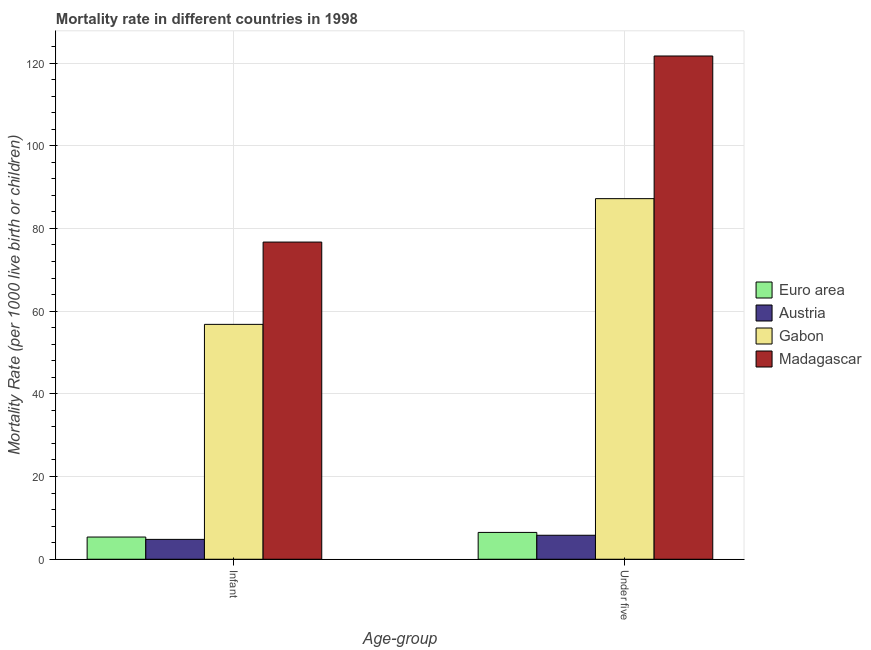What is the label of the 2nd group of bars from the left?
Ensure brevity in your answer.  Under five. Across all countries, what is the maximum under-5 mortality rate?
Offer a terse response. 121.7. In which country was the infant mortality rate maximum?
Provide a short and direct response. Madagascar. In which country was the infant mortality rate minimum?
Give a very brief answer. Austria. What is the total under-5 mortality rate in the graph?
Your answer should be compact. 221.19. What is the difference between the infant mortality rate in Austria and that in Gabon?
Provide a succinct answer. -52. What is the difference between the infant mortality rate in Austria and the under-5 mortality rate in Madagascar?
Your answer should be very brief. -116.9. What is the average infant mortality rate per country?
Provide a short and direct response. 35.92. What is the difference between the infant mortality rate and under-5 mortality rate in Gabon?
Offer a very short reply. -30.4. In how many countries, is the under-5 mortality rate greater than 60 ?
Your answer should be very brief. 2. What is the ratio of the infant mortality rate in Madagascar to that in Euro area?
Provide a short and direct response. 14.29. Is the under-5 mortality rate in Euro area less than that in Madagascar?
Your response must be concise. Yes. What does the 1st bar from the left in Under five represents?
Make the answer very short. Euro area. What is the difference between two consecutive major ticks on the Y-axis?
Offer a terse response. 20. Are the values on the major ticks of Y-axis written in scientific E-notation?
Your response must be concise. No. Does the graph contain any zero values?
Provide a succinct answer. No. Where does the legend appear in the graph?
Your answer should be compact. Center right. How many legend labels are there?
Offer a very short reply. 4. How are the legend labels stacked?
Keep it short and to the point. Vertical. What is the title of the graph?
Give a very brief answer. Mortality rate in different countries in 1998. Does "Kenya" appear as one of the legend labels in the graph?
Give a very brief answer. No. What is the label or title of the X-axis?
Keep it short and to the point. Age-group. What is the label or title of the Y-axis?
Your answer should be compact. Mortality Rate (per 1000 live birth or children). What is the Mortality Rate (per 1000 live birth or children) of Euro area in Infant?
Offer a terse response. 5.37. What is the Mortality Rate (per 1000 live birth or children) of Gabon in Infant?
Your answer should be very brief. 56.8. What is the Mortality Rate (per 1000 live birth or children) of Madagascar in Infant?
Provide a succinct answer. 76.7. What is the Mortality Rate (per 1000 live birth or children) of Euro area in Under five?
Give a very brief answer. 6.49. What is the Mortality Rate (per 1000 live birth or children) in Austria in Under five?
Provide a succinct answer. 5.8. What is the Mortality Rate (per 1000 live birth or children) in Gabon in Under five?
Ensure brevity in your answer.  87.2. What is the Mortality Rate (per 1000 live birth or children) of Madagascar in Under five?
Keep it short and to the point. 121.7. Across all Age-group, what is the maximum Mortality Rate (per 1000 live birth or children) in Euro area?
Make the answer very short. 6.49. Across all Age-group, what is the maximum Mortality Rate (per 1000 live birth or children) in Austria?
Your answer should be compact. 5.8. Across all Age-group, what is the maximum Mortality Rate (per 1000 live birth or children) in Gabon?
Provide a short and direct response. 87.2. Across all Age-group, what is the maximum Mortality Rate (per 1000 live birth or children) in Madagascar?
Offer a very short reply. 121.7. Across all Age-group, what is the minimum Mortality Rate (per 1000 live birth or children) of Euro area?
Offer a very short reply. 5.37. Across all Age-group, what is the minimum Mortality Rate (per 1000 live birth or children) in Gabon?
Provide a short and direct response. 56.8. Across all Age-group, what is the minimum Mortality Rate (per 1000 live birth or children) in Madagascar?
Offer a terse response. 76.7. What is the total Mortality Rate (per 1000 live birth or children) in Euro area in the graph?
Your response must be concise. 11.85. What is the total Mortality Rate (per 1000 live birth or children) in Gabon in the graph?
Ensure brevity in your answer.  144. What is the total Mortality Rate (per 1000 live birth or children) in Madagascar in the graph?
Provide a short and direct response. 198.4. What is the difference between the Mortality Rate (per 1000 live birth or children) in Euro area in Infant and that in Under five?
Provide a succinct answer. -1.12. What is the difference between the Mortality Rate (per 1000 live birth or children) in Gabon in Infant and that in Under five?
Keep it short and to the point. -30.4. What is the difference between the Mortality Rate (per 1000 live birth or children) in Madagascar in Infant and that in Under five?
Your answer should be compact. -45. What is the difference between the Mortality Rate (per 1000 live birth or children) in Euro area in Infant and the Mortality Rate (per 1000 live birth or children) in Austria in Under five?
Your answer should be very brief. -0.43. What is the difference between the Mortality Rate (per 1000 live birth or children) in Euro area in Infant and the Mortality Rate (per 1000 live birth or children) in Gabon in Under five?
Keep it short and to the point. -81.83. What is the difference between the Mortality Rate (per 1000 live birth or children) in Euro area in Infant and the Mortality Rate (per 1000 live birth or children) in Madagascar in Under five?
Your response must be concise. -116.33. What is the difference between the Mortality Rate (per 1000 live birth or children) of Austria in Infant and the Mortality Rate (per 1000 live birth or children) of Gabon in Under five?
Your answer should be very brief. -82.4. What is the difference between the Mortality Rate (per 1000 live birth or children) in Austria in Infant and the Mortality Rate (per 1000 live birth or children) in Madagascar in Under five?
Your answer should be compact. -116.9. What is the difference between the Mortality Rate (per 1000 live birth or children) in Gabon in Infant and the Mortality Rate (per 1000 live birth or children) in Madagascar in Under five?
Offer a very short reply. -64.9. What is the average Mortality Rate (per 1000 live birth or children) in Euro area per Age-group?
Provide a succinct answer. 5.93. What is the average Mortality Rate (per 1000 live birth or children) in Austria per Age-group?
Make the answer very short. 5.3. What is the average Mortality Rate (per 1000 live birth or children) in Madagascar per Age-group?
Provide a short and direct response. 99.2. What is the difference between the Mortality Rate (per 1000 live birth or children) of Euro area and Mortality Rate (per 1000 live birth or children) of Austria in Infant?
Keep it short and to the point. 0.57. What is the difference between the Mortality Rate (per 1000 live birth or children) in Euro area and Mortality Rate (per 1000 live birth or children) in Gabon in Infant?
Offer a terse response. -51.43. What is the difference between the Mortality Rate (per 1000 live birth or children) in Euro area and Mortality Rate (per 1000 live birth or children) in Madagascar in Infant?
Ensure brevity in your answer.  -71.33. What is the difference between the Mortality Rate (per 1000 live birth or children) of Austria and Mortality Rate (per 1000 live birth or children) of Gabon in Infant?
Make the answer very short. -52. What is the difference between the Mortality Rate (per 1000 live birth or children) in Austria and Mortality Rate (per 1000 live birth or children) in Madagascar in Infant?
Offer a very short reply. -71.9. What is the difference between the Mortality Rate (per 1000 live birth or children) in Gabon and Mortality Rate (per 1000 live birth or children) in Madagascar in Infant?
Keep it short and to the point. -19.9. What is the difference between the Mortality Rate (per 1000 live birth or children) of Euro area and Mortality Rate (per 1000 live birth or children) of Austria in Under five?
Provide a short and direct response. 0.69. What is the difference between the Mortality Rate (per 1000 live birth or children) in Euro area and Mortality Rate (per 1000 live birth or children) in Gabon in Under five?
Provide a short and direct response. -80.71. What is the difference between the Mortality Rate (per 1000 live birth or children) in Euro area and Mortality Rate (per 1000 live birth or children) in Madagascar in Under five?
Your answer should be very brief. -115.21. What is the difference between the Mortality Rate (per 1000 live birth or children) in Austria and Mortality Rate (per 1000 live birth or children) in Gabon in Under five?
Make the answer very short. -81.4. What is the difference between the Mortality Rate (per 1000 live birth or children) of Austria and Mortality Rate (per 1000 live birth or children) of Madagascar in Under five?
Make the answer very short. -115.9. What is the difference between the Mortality Rate (per 1000 live birth or children) of Gabon and Mortality Rate (per 1000 live birth or children) of Madagascar in Under five?
Offer a very short reply. -34.5. What is the ratio of the Mortality Rate (per 1000 live birth or children) in Euro area in Infant to that in Under five?
Offer a very short reply. 0.83. What is the ratio of the Mortality Rate (per 1000 live birth or children) of Austria in Infant to that in Under five?
Ensure brevity in your answer.  0.83. What is the ratio of the Mortality Rate (per 1000 live birth or children) of Gabon in Infant to that in Under five?
Keep it short and to the point. 0.65. What is the ratio of the Mortality Rate (per 1000 live birth or children) in Madagascar in Infant to that in Under five?
Provide a succinct answer. 0.63. What is the difference between the highest and the second highest Mortality Rate (per 1000 live birth or children) of Euro area?
Provide a short and direct response. 1.12. What is the difference between the highest and the second highest Mortality Rate (per 1000 live birth or children) in Gabon?
Offer a very short reply. 30.4. What is the difference between the highest and the lowest Mortality Rate (per 1000 live birth or children) of Euro area?
Your answer should be very brief. 1.12. What is the difference between the highest and the lowest Mortality Rate (per 1000 live birth or children) of Gabon?
Your response must be concise. 30.4. What is the difference between the highest and the lowest Mortality Rate (per 1000 live birth or children) of Madagascar?
Keep it short and to the point. 45. 